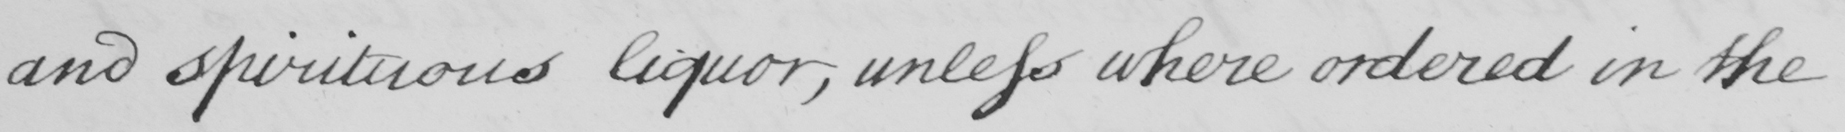Can you read and transcribe this handwriting? and spirituous liquor, unless where ordered in the 